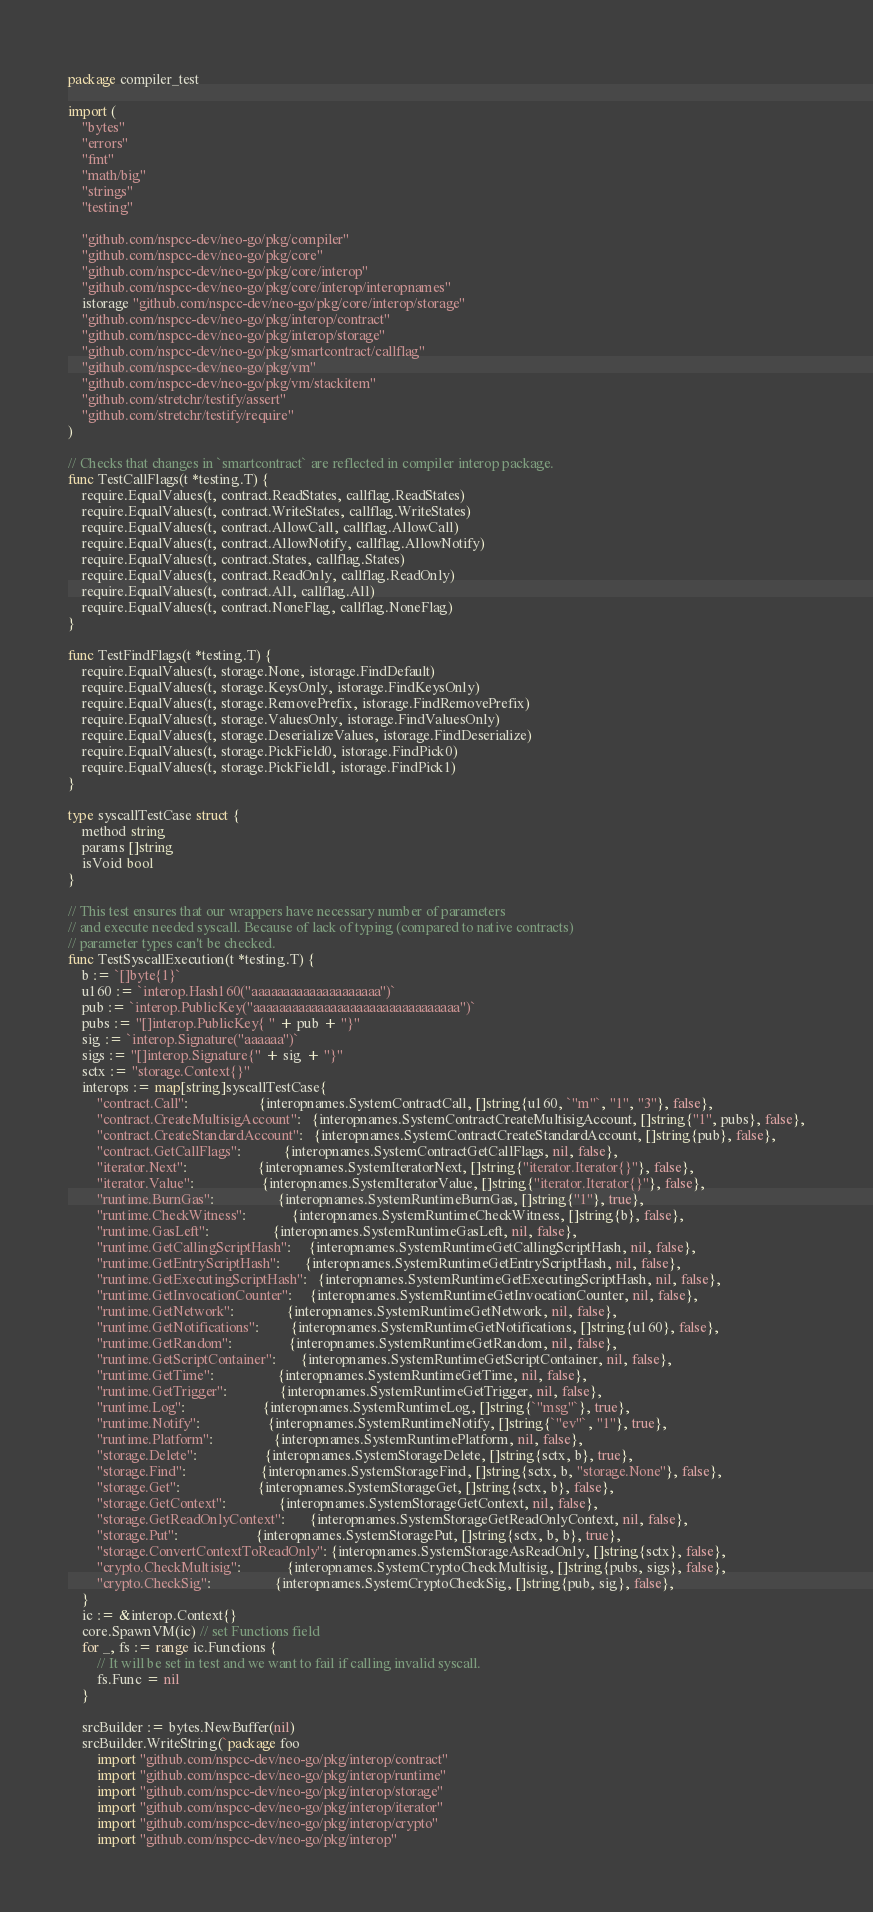Convert code to text. <code><loc_0><loc_0><loc_500><loc_500><_Go_>package compiler_test

import (
	"bytes"
	"errors"
	"fmt"
	"math/big"
	"strings"
	"testing"

	"github.com/nspcc-dev/neo-go/pkg/compiler"
	"github.com/nspcc-dev/neo-go/pkg/core"
	"github.com/nspcc-dev/neo-go/pkg/core/interop"
	"github.com/nspcc-dev/neo-go/pkg/core/interop/interopnames"
	istorage "github.com/nspcc-dev/neo-go/pkg/core/interop/storage"
	"github.com/nspcc-dev/neo-go/pkg/interop/contract"
	"github.com/nspcc-dev/neo-go/pkg/interop/storage"
	"github.com/nspcc-dev/neo-go/pkg/smartcontract/callflag"
	"github.com/nspcc-dev/neo-go/pkg/vm"
	"github.com/nspcc-dev/neo-go/pkg/vm/stackitem"
	"github.com/stretchr/testify/assert"
	"github.com/stretchr/testify/require"
)

// Checks that changes in `smartcontract` are reflected in compiler interop package.
func TestCallFlags(t *testing.T) {
	require.EqualValues(t, contract.ReadStates, callflag.ReadStates)
	require.EqualValues(t, contract.WriteStates, callflag.WriteStates)
	require.EqualValues(t, contract.AllowCall, callflag.AllowCall)
	require.EqualValues(t, contract.AllowNotify, callflag.AllowNotify)
	require.EqualValues(t, contract.States, callflag.States)
	require.EqualValues(t, contract.ReadOnly, callflag.ReadOnly)
	require.EqualValues(t, contract.All, callflag.All)
	require.EqualValues(t, contract.NoneFlag, callflag.NoneFlag)
}

func TestFindFlags(t *testing.T) {
	require.EqualValues(t, storage.None, istorage.FindDefault)
	require.EqualValues(t, storage.KeysOnly, istorage.FindKeysOnly)
	require.EqualValues(t, storage.RemovePrefix, istorage.FindRemovePrefix)
	require.EqualValues(t, storage.ValuesOnly, istorage.FindValuesOnly)
	require.EqualValues(t, storage.DeserializeValues, istorage.FindDeserialize)
	require.EqualValues(t, storage.PickField0, istorage.FindPick0)
	require.EqualValues(t, storage.PickField1, istorage.FindPick1)
}

type syscallTestCase struct {
	method string
	params []string
	isVoid bool
}

// This test ensures that our wrappers have necessary number of parameters
// and execute needed syscall. Because of lack of typing (compared to native contracts)
// parameter types can't be checked.
func TestSyscallExecution(t *testing.T) {
	b := `[]byte{1}`
	u160 := `interop.Hash160("aaaaaaaaaaaaaaaaaaaa")`
	pub := `interop.PublicKey("aaaaaaaaaaaaaaaaaaaaaaaaaaaaaaaa")`
	pubs := "[]interop.PublicKey{ " + pub + "}"
	sig := `interop.Signature("aaaaaa")`
	sigs := "[]interop.Signature{" + sig + "}"
	sctx := "storage.Context{}"
	interops := map[string]syscallTestCase{
		"contract.Call":                    {interopnames.SystemContractCall, []string{u160, `"m"`, "1", "3"}, false},
		"contract.CreateMultisigAccount":   {interopnames.SystemContractCreateMultisigAccount, []string{"1", pubs}, false},
		"contract.CreateStandardAccount":   {interopnames.SystemContractCreateStandardAccount, []string{pub}, false},
		"contract.GetCallFlags":            {interopnames.SystemContractGetCallFlags, nil, false},
		"iterator.Next":                    {interopnames.SystemIteratorNext, []string{"iterator.Iterator{}"}, false},
		"iterator.Value":                   {interopnames.SystemIteratorValue, []string{"iterator.Iterator{}"}, false},
		"runtime.BurnGas":                  {interopnames.SystemRuntimeBurnGas, []string{"1"}, true},
		"runtime.CheckWitness":             {interopnames.SystemRuntimeCheckWitness, []string{b}, false},
		"runtime.GasLeft":                  {interopnames.SystemRuntimeGasLeft, nil, false},
		"runtime.GetCallingScriptHash":     {interopnames.SystemRuntimeGetCallingScriptHash, nil, false},
		"runtime.GetEntryScriptHash":       {interopnames.SystemRuntimeGetEntryScriptHash, nil, false},
		"runtime.GetExecutingScriptHash":   {interopnames.SystemRuntimeGetExecutingScriptHash, nil, false},
		"runtime.GetInvocationCounter":     {interopnames.SystemRuntimeGetInvocationCounter, nil, false},
		"runtime.GetNetwork":               {interopnames.SystemRuntimeGetNetwork, nil, false},
		"runtime.GetNotifications":         {interopnames.SystemRuntimeGetNotifications, []string{u160}, false},
		"runtime.GetRandom":                {interopnames.SystemRuntimeGetRandom, nil, false},
		"runtime.GetScriptContainer":       {interopnames.SystemRuntimeGetScriptContainer, nil, false},
		"runtime.GetTime":                  {interopnames.SystemRuntimeGetTime, nil, false},
		"runtime.GetTrigger":               {interopnames.SystemRuntimeGetTrigger, nil, false},
		"runtime.Log":                      {interopnames.SystemRuntimeLog, []string{`"msg"`}, true},
		"runtime.Notify":                   {interopnames.SystemRuntimeNotify, []string{`"ev"`, "1"}, true},
		"runtime.Platform":                 {interopnames.SystemRuntimePlatform, nil, false},
		"storage.Delete":                   {interopnames.SystemStorageDelete, []string{sctx, b}, true},
		"storage.Find":                     {interopnames.SystemStorageFind, []string{sctx, b, "storage.None"}, false},
		"storage.Get":                      {interopnames.SystemStorageGet, []string{sctx, b}, false},
		"storage.GetContext":               {interopnames.SystemStorageGetContext, nil, false},
		"storage.GetReadOnlyContext":       {interopnames.SystemStorageGetReadOnlyContext, nil, false},
		"storage.Put":                      {interopnames.SystemStoragePut, []string{sctx, b, b}, true},
		"storage.ConvertContextToReadOnly": {interopnames.SystemStorageAsReadOnly, []string{sctx}, false},
		"crypto.CheckMultisig":             {interopnames.SystemCryptoCheckMultisig, []string{pubs, sigs}, false},
		"crypto.CheckSig":                  {interopnames.SystemCryptoCheckSig, []string{pub, sig}, false},
	}
	ic := &interop.Context{}
	core.SpawnVM(ic) // set Functions field
	for _, fs := range ic.Functions {
		// It will be set in test and we want to fail if calling invalid syscall.
		fs.Func = nil
	}

	srcBuilder := bytes.NewBuffer(nil)
	srcBuilder.WriteString(`package foo
		import "github.com/nspcc-dev/neo-go/pkg/interop/contract"
		import "github.com/nspcc-dev/neo-go/pkg/interop/runtime"
		import "github.com/nspcc-dev/neo-go/pkg/interop/storage"
		import "github.com/nspcc-dev/neo-go/pkg/interop/iterator"
		import "github.com/nspcc-dev/neo-go/pkg/interop/crypto"
		import "github.com/nspcc-dev/neo-go/pkg/interop"</code> 